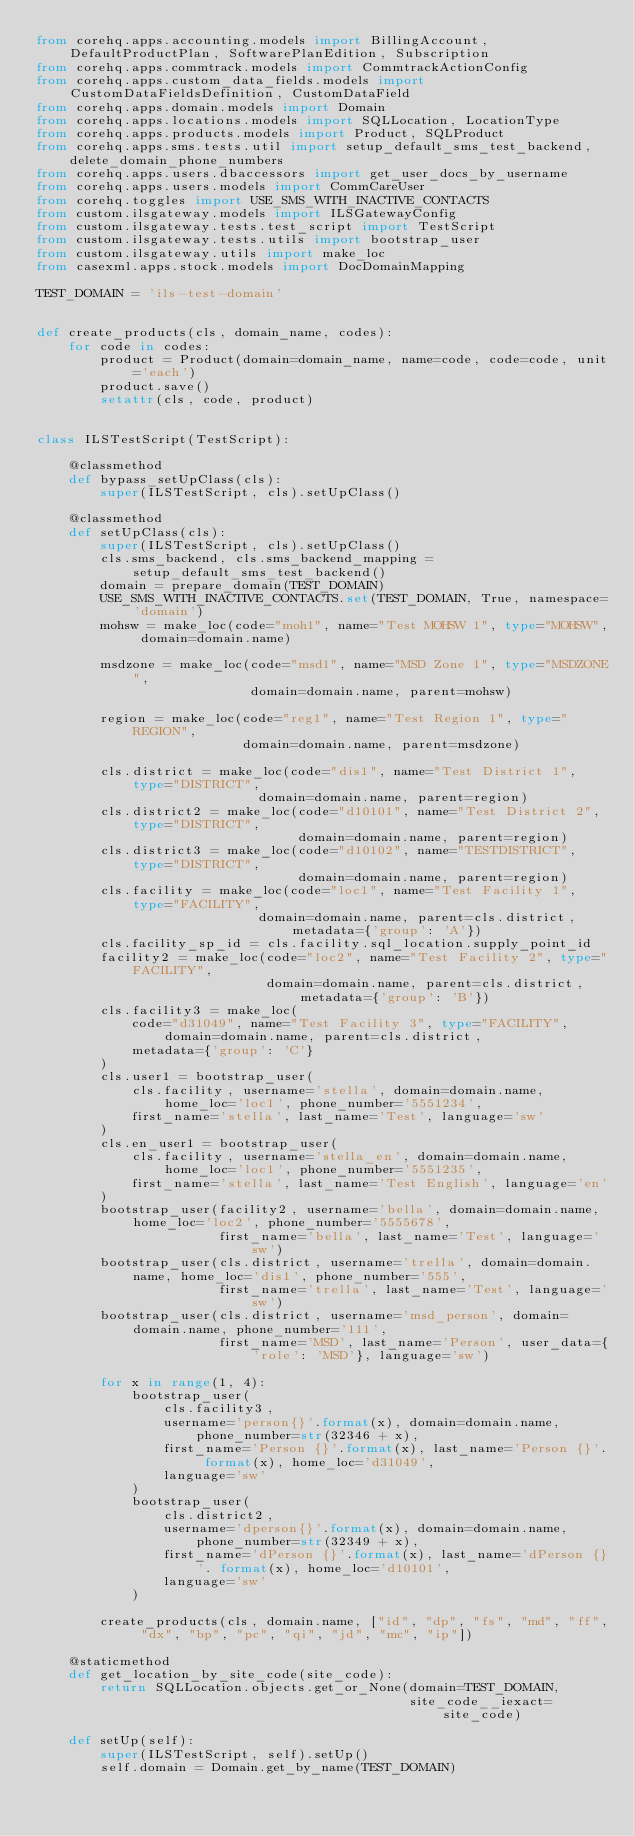Convert code to text. <code><loc_0><loc_0><loc_500><loc_500><_Python_>from corehq.apps.accounting.models import BillingAccount, DefaultProductPlan, SoftwarePlanEdition, Subscription
from corehq.apps.commtrack.models import CommtrackActionConfig
from corehq.apps.custom_data_fields.models import CustomDataFieldsDefinition, CustomDataField
from corehq.apps.domain.models import Domain
from corehq.apps.locations.models import SQLLocation, LocationType
from corehq.apps.products.models import Product, SQLProduct
from corehq.apps.sms.tests.util import setup_default_sms_test_backend, delete_domain_phone_numbers
from corehq.apps.users.dbaccessors import get_user_docs_by_username
from corehq.apps.users.models import CommCareUser
from corehq.toggles import USE_SMS_WITH_INACTIVE_CONTACTS
from custom.ilsgateway.models import ILSGatewayConfig
from custom.ilsgateway.tests.test_script import TestScript
from custom.ilsgateway.tests.utils import bootstrap_user
from custom.ilsgateway.utils import make_loc
from casexml.apps.stock.models import DocDomainMapping

TEST_DOMAIN = 'ils-test-domain'


def create_products(cls, domain_name, codes):
    for code in codes:
        product = Product(domain=domain_name, name=code, code=code, unit='each')
        product.save()
        setattr(cls, code, product)


class ILSTestScript(TestScript):

    @classmethod
    def bypass_setUpClass(cls):
        super(ILSTestScript, cls).setUpClass()

    @classmethod
    def setUpClass(cls):
        super(ILSTestScript, cls).setUpClass()
        cls.sms_backend, cls.sms_backend_mapping = setup_default_sms_test_backend()
        domain = prepare_domain(TEST_DOMAIN)
        USE_SMS_WITH_INACTIVE_CONTACTS.set(TEST_DOMAIN, True, namespace='domain')
        mohsw = make_loc(code="moh1", name="Test MOHSW 1", type="MOHSW", domain=domain.name)

        msdzone = make_loc(code="msd1", name="MSD Zone 1", type="MSDZONE",
                           domain=domain.name, parent=mohsw)

        region = make_loc(code="reg1", name="Test Region 1", type="REGION",
                          domain=domain.name, parent=msdzone)

        cls.district = make_loc(code="dis1", name="Test District 1", type="DISTRICT",
                            domain=domain.name, parent=region)
        cls.district2 = make_loc(code="d10101", name="Test District 2", type="DISTRICT",
                                 domain=domain.name, parent=region)
        cls.district3 = make_loc(code="d10102", name="TESTDISTRICT", type="DISTRICT",
                                 domain=domain.name, parent=region)
        cls.facility = make_loc(code="loc1", name="Test Facility 1", type="FACILITY",
                            domain=domain.name, parent=cls.district, metadata={'group': 'A'})
        cls.facility_sp_id = cls.facility.sql_location.supply_point_id
        facility2 = make_loc(code="loc2", name="Test Facility 2", type="FACILITY",
                             domain=domain.name, parent=cls.district, metadata={'group': 'B'})
        cls.facility3 = make_loc(
            code="d31049", name="Test Facility 3", type="FACILITY", domain=domain.name, parent=cls.district,
            metadata={'group': 'C'}
        )
        cls.user1 = bootstrap_user(
            cls.facility, username='stella', domain=domain.name, home_loc='loc1', phone_number='5551234',
            first_name='stella', last_name='Test', language='sw'
        )
        cls.en_user1 = bootstrap_user(
            cls.facility, username='stella_en', domain=domain.name, home_loc='loc1', phone_number='5551235',
            first_name='stella', last_name='Test English', language='en'
        )
        bootstrap_user(facility2, username='bella', domain=domain.name, home_loc='loc2', phone_number='5555678',
                       first_name='bella', last_name='Test', language='sw')
        bootstrap_user(cls.district, username='trella', domain=domain.name, home_loc='dis1', phone_number='555',
                       first_name='trella', last_name='Test', language='sw')
        bootstrap_user(cls.district, username='msd_person', domain=domain.name, phone_number='111',
                       first_name='MSD', last_name='Person', user_data={'role': 'MSD'}, language='sw')

        for x in range(1, 4):
            bootstrap_user(
                cls.facility3,
                username='person{}'.format(x), domain=domain.name, phone_number=str(32346 + x),
                first_name='Person {}'.format(x), last_name='Person {}'. format(x), home_loc='d31049',
                language='sw'
            )
            bootstrap_user(
                cls.district2,
                username='dperson{}'.format(x), domain=domain.name, phone_number=str(32349 + x),
                first_name='dPerson {}'.format(x), last_name='dPerson {}'. format(x), home_loc='d10101',
                language='sw'
            )

        create_products(cls, domain.name, ["id", "dp", "fs", "md", "ff", "dx", "bp", "pc", "qi", "jd", "mc", "ip"])

    @staticmethod
    def get_location_by_site_code(site_code):
        return SQLLocation.objects.get_or_None(domain=TEST_DOMAIN,
                                               site_code__iexact=site_code)

    def setUp(self):
        super(ILSTestScript, self).setUp()
        self.domain = Domain.get_by_name(TEST_DOMAIN)</code> 